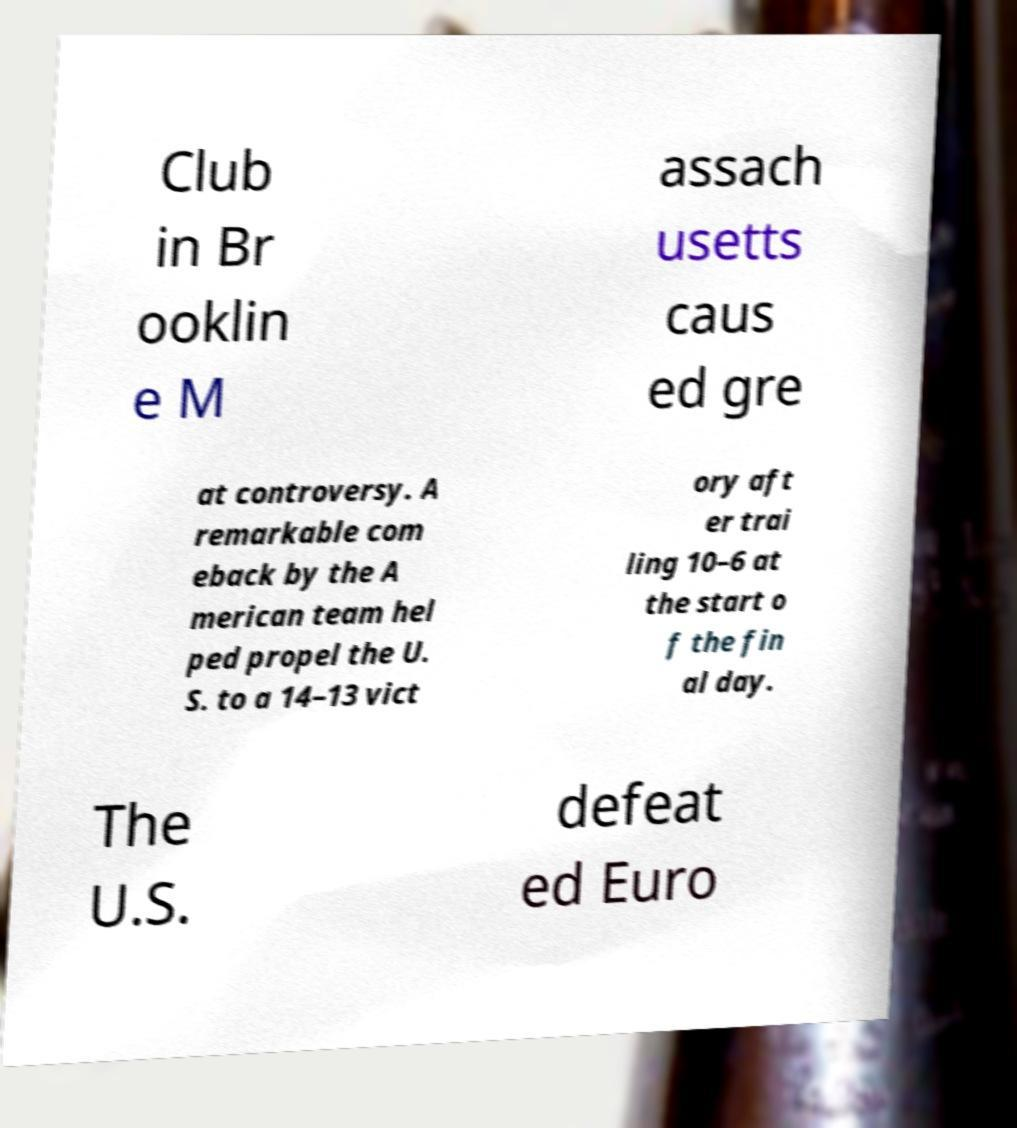Could you assist in decoding the text presented in this image and type it out clearly? Club in Br ooklin e M assach usetts caus ed gre at controversy. A remarkable com eback by the A merican team hel ped propel the U. S. to a 14–13 vict ory aft er trai ling 10–6 at the start o f the fin al day. The U.S. defeat ed Euro 